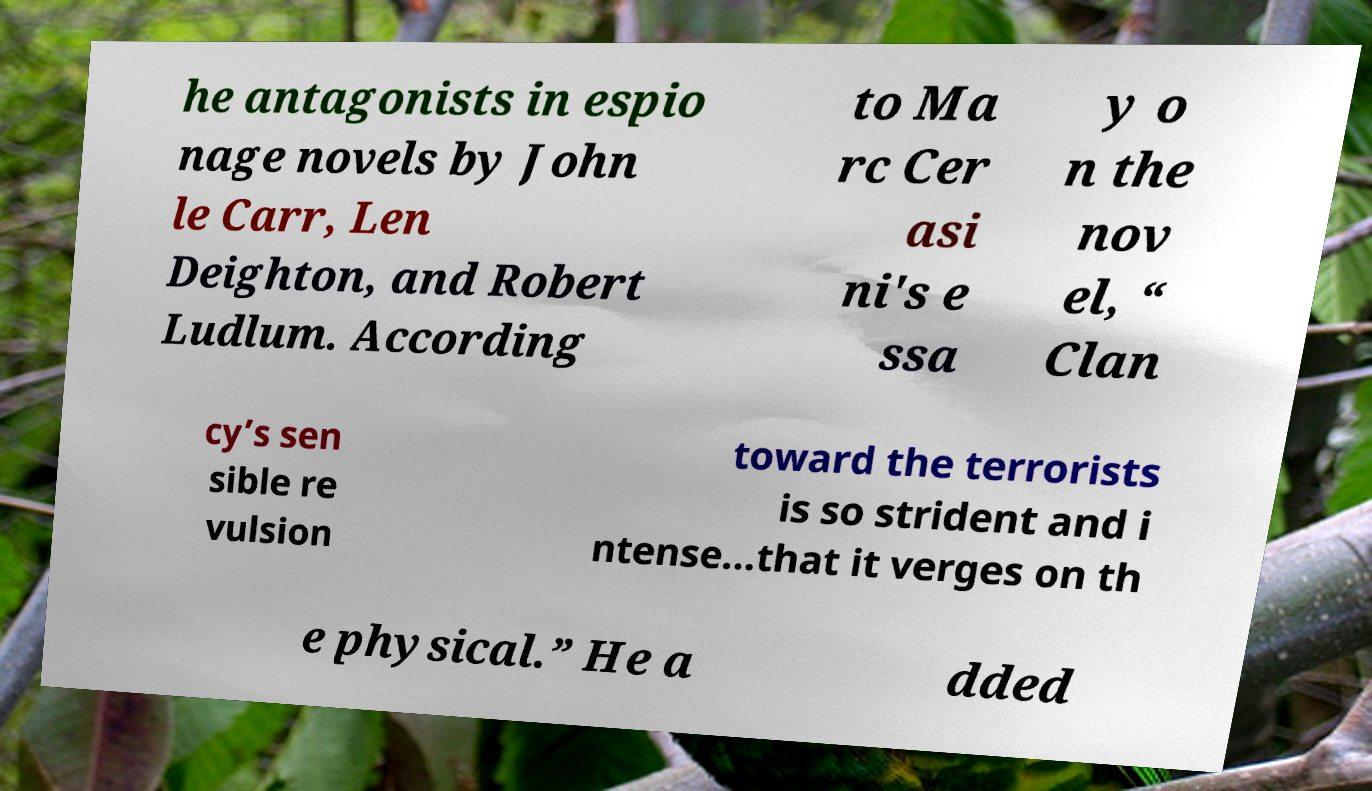What messages or text are displayed in this image? I need them in a readable, typed format. he antagonists in espio nage novels by John le Carr, Len Deighton, and Robert Ludlum. According to Ma rc Cer asi ni's e ssa y o n the nov el, “ Clan cy’s sen sible re vulsion toward the terrorists is so strident and i ntense...that it verges on th e physical.” He a dded 